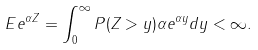<formula> <loc_0><loc_0><loc_500><loc_500>E e ^ { \alpha Z } = \int _ { 0 } ^ { \infty } P ( Z > y ) \alpha e ^ { \alpha y } d y < \infty .</formula> 